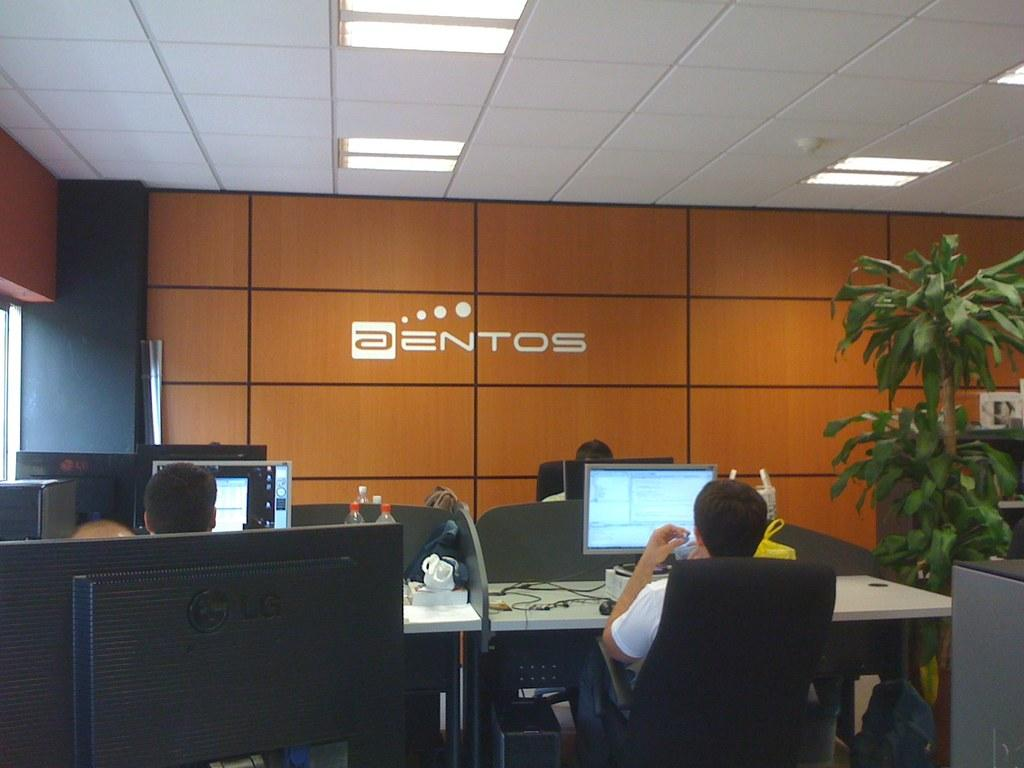<image>
Present a compact description of the photo's key features. A man sitting at a desk with a monitor at the Aentos office. 